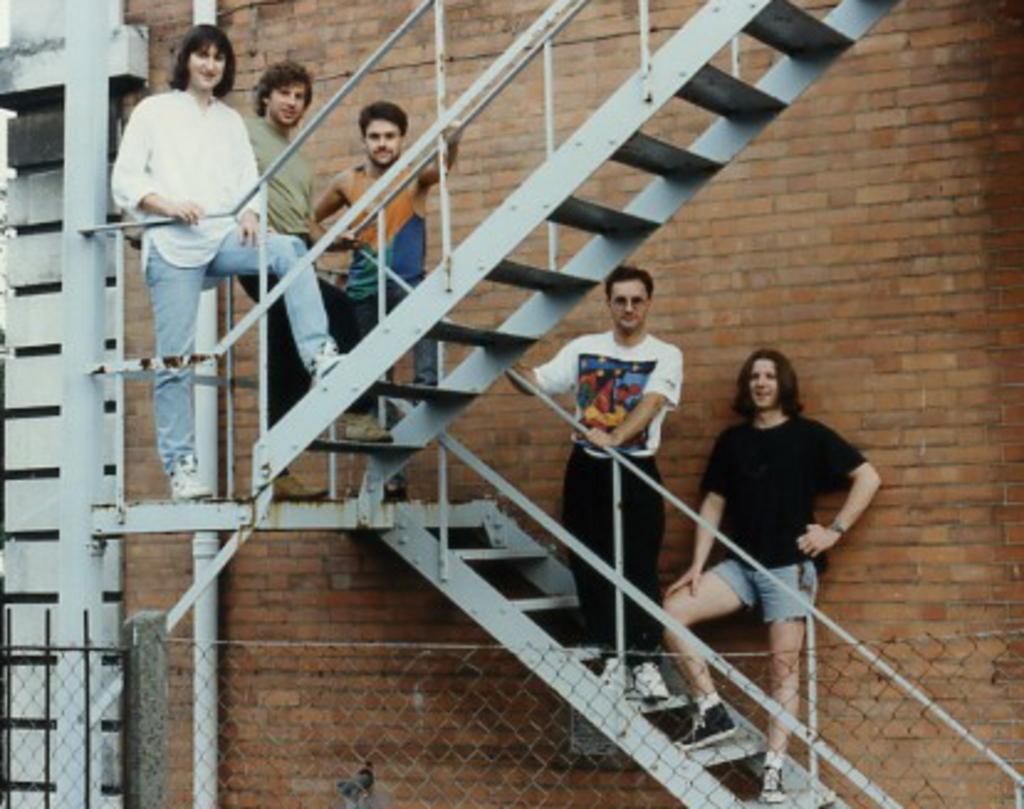Can you describe this image briefly? In this picture there are people standing on the staircases. On the left there are pipe, railing and wall. In the background it is brick wall. In the foreground there is fencing. 